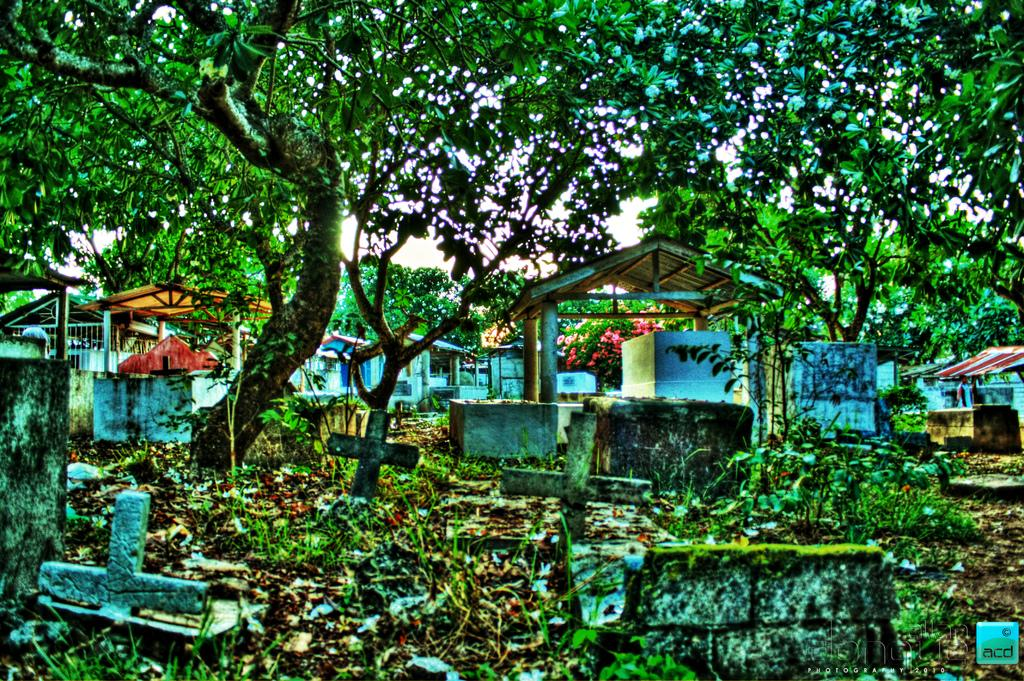What type of location is depicted in the image? The image depicts a graveyard. What can be seen on the ground in the image? There are grave stones in the image. Are there any structures in the image besides the grave stones? Yes, there are sheds in the image. What type of vegetation is present in the image? There are trees in the image. What is the condition of the sky in the image? The sky is clear in the image. What type of wrench is being used to repair the tent in the image? There is no wrench or tent present in the image; it depicts a graveyard with grave stones, sheds, trees, and a clear sky. 